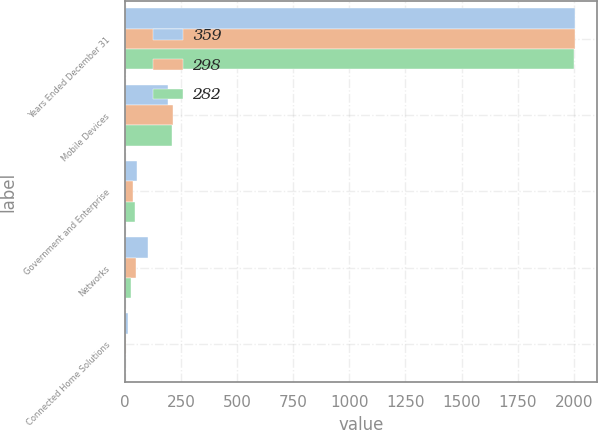Convert chart to OTSL. <chart><loc_0><loc_0><loc_500><loc_500><stacked_bar_chart><ecel><fcel>Years Ended December 31<fcel>Mobile Devices<fcel>Government and Enterprise<fcel>Networks<fcel>Connected Home Solutions<nl><fcel>359<fcel>2005<fcel>189<fcel>54<fcel>102<fcel>14<nl><fcel>298<fcel>2004<fcel>212<fcel>33<fcel>49<fcel>4<nl><fcel>282<fcel>2003<fcel>209<fcel>46<fcel>26<fcel>1<nl></chart> 